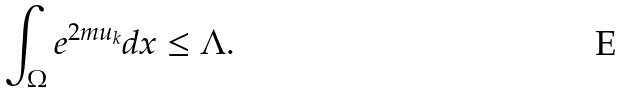Convert formula to latex. <formula><loc_0><loc_0><loc_500><loc_500>\int _ { \Omega } e ^ { 2 m u _ { k } } d x \leq \Lambda .</formula> 